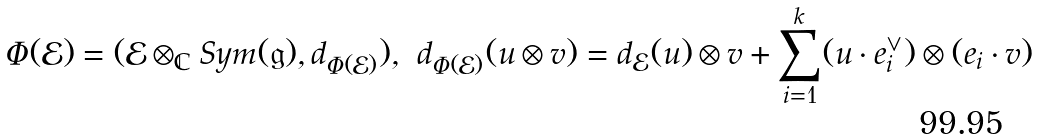Convert formula to latex. <formula><loc_0><loc_0><loc_500><loc_500>\Phi ( \mathcal { E } ) = ( \mathcal { E } \otimes _ { \mathbb { C } } S y m ( \mathfrak { g } ) , d _ { \Phi ( \mathcal { E } ) } ) , \ d _ { \Phi ( \mathcal { E } ) } ( u \otimes v ) = d _ { \mathcal { E } } ( u ) \otimes v + \sum _ { i = 1 } ^ { k } ( u \cdot e _ { i } ^ { \vee } ) \otimes ( e _ { i } \cdot v )</formula> 